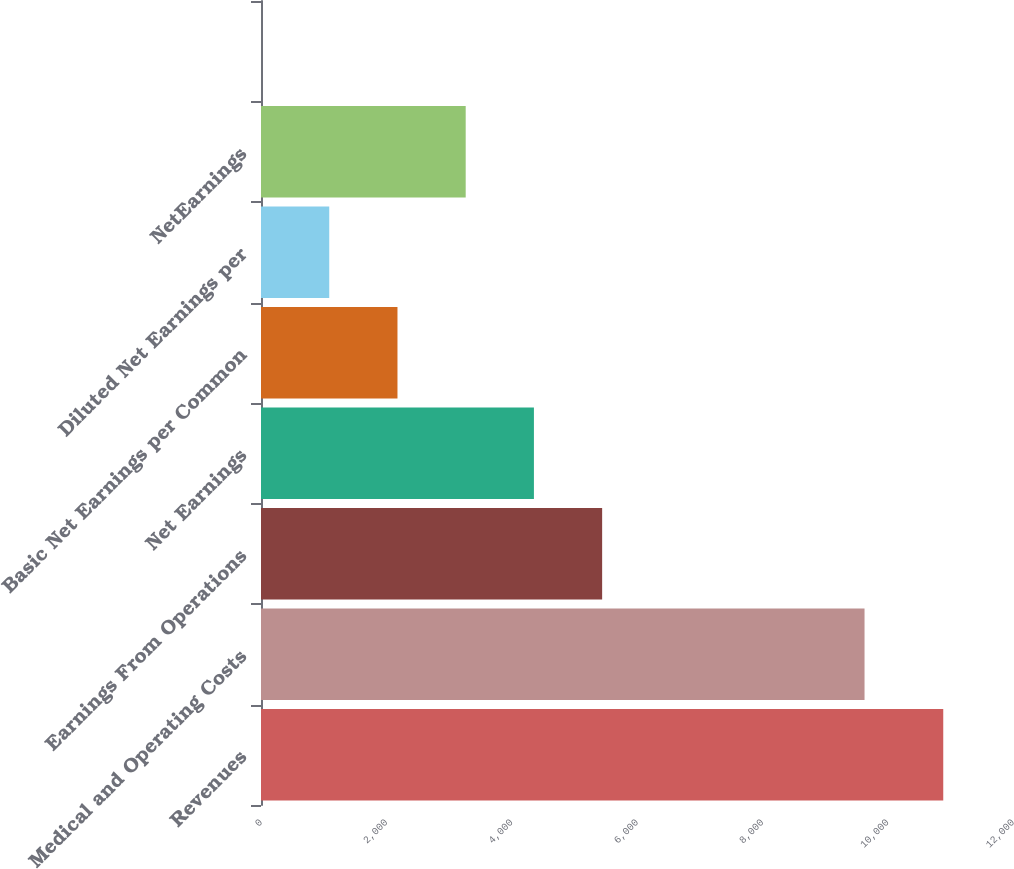<chart> <loc_0><loc_0><loc_500><loc_500><bar_chart><fcel>Revenues<fcel>Medical and Operating Costs<fcel>Earnings From Operations<fcel>Net Earnings<fcel>Basic Net Earnings per Common<fcel>Diluted Net Earnings per<fcel>NetEarnings<fcel>Unnamed: 7<nl><fcel>10887<fcel>9631<fcel>5443.74<fcel>4355.08<fcel>2177.76<fcel>1089.1<fcel>3266.42<fcel>0.44<nl></chart> 